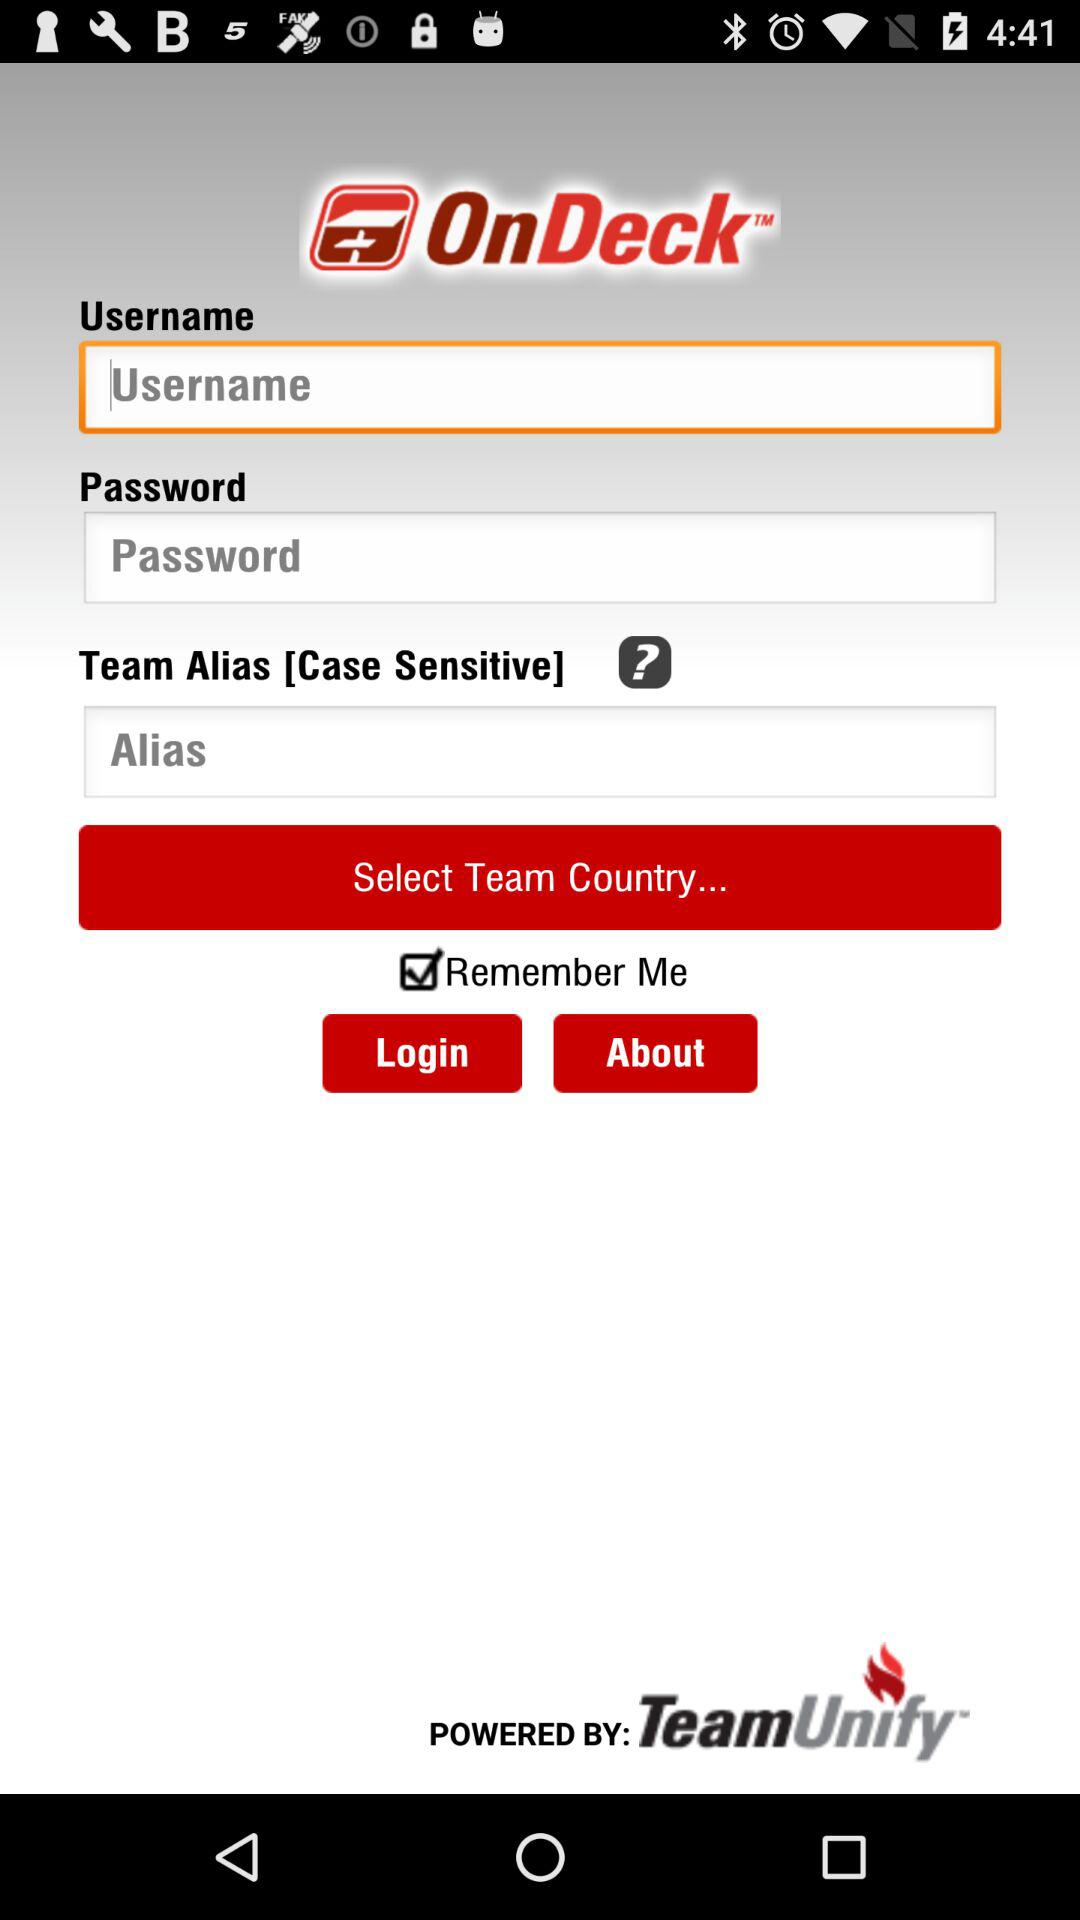How many text input fields are there on this screen?
Answer the question using a single word or phrase. 3 